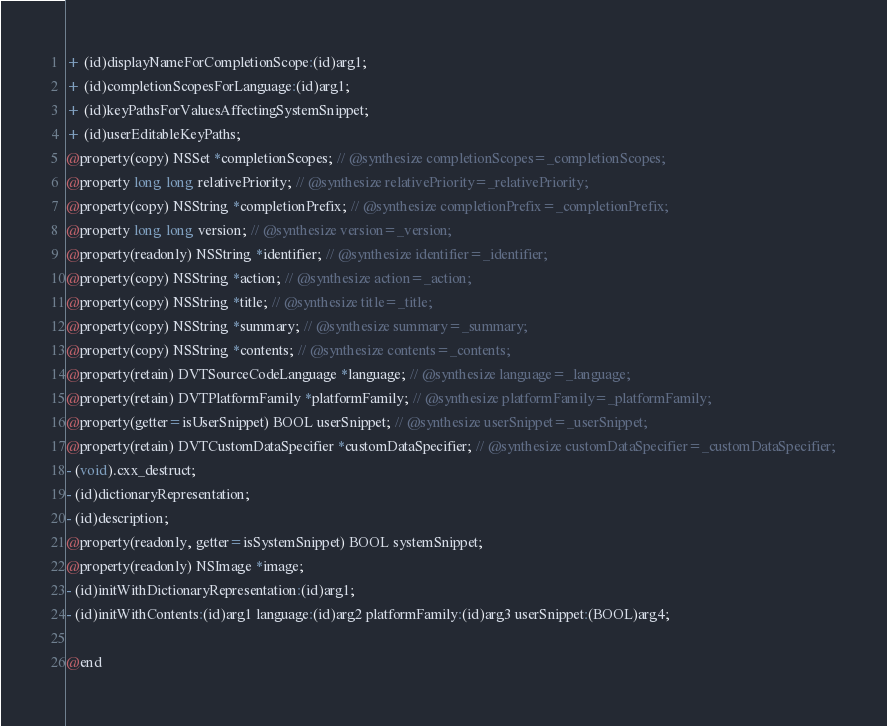Convert code to text. <code><loc_0><loc_0><loc_500><loc_500><_C_>
+ (id)displayNameForCompletionScope:(id)arg1;
+ (id)completionScopesForLanguage:(id)arg1;
+ (id)keyPathsForValuesAffectingSystemSnippet;
+ (id)userEditableKeyPaths;
@property(copy) NSSet *completionScopes; // @synthesize completionScopes=_completionScopes;
@property long long relativePriority; // @synthesize relativePriority=_relativePriority;
@property(copy) NSString *completionPrefix; // @synthesize completionPrefix=_completionPrefix;
@property long long version; // @synthesize version=_version;
@property(readonly) NSString *identifier; // @synthesize identifier=_identifier;
@property(copy) NSString *action; // @synthesize action=_action;
@property(copy) NSString *title; // @synthesize title=_title;
@property(copy) NSString *summary; // @synthesize summary=_summary;
@property(copy) NSString *contents; // @synthesize contents=_contents;
@property(retain) DVTSourceCodeLanguage *language; // @synthesize language=_language;
@property(retain) DVTPlatformFamily *platformFamily; // @synthesize platformFamily=_platformFamily;
@property(getter=isUserSnippet) BOOL userSnippet; // @synthesize userSnippet=_userSnippet;
@property(retain) DVTCustomDataSpecifier *customDataSpecifier; // @synthesize customDataSpecifier=_customDataSpecifier;
- (void).cxx_destruct;
- (id)dictionaryRepresentation;
- (id)description;
@property(readonly, getter=isSystemSnippet) BOOL systemSnippet;
@property(readonly) NSImage *image;
- (id)initWithDictionaryRepresentation:(id)arg1;
- (id)initWithContents:(id)arg1 language:(id)arg2 platformFamily:(id)arg3 userSnippet:(BOOL)arg4;

@end

</code> 